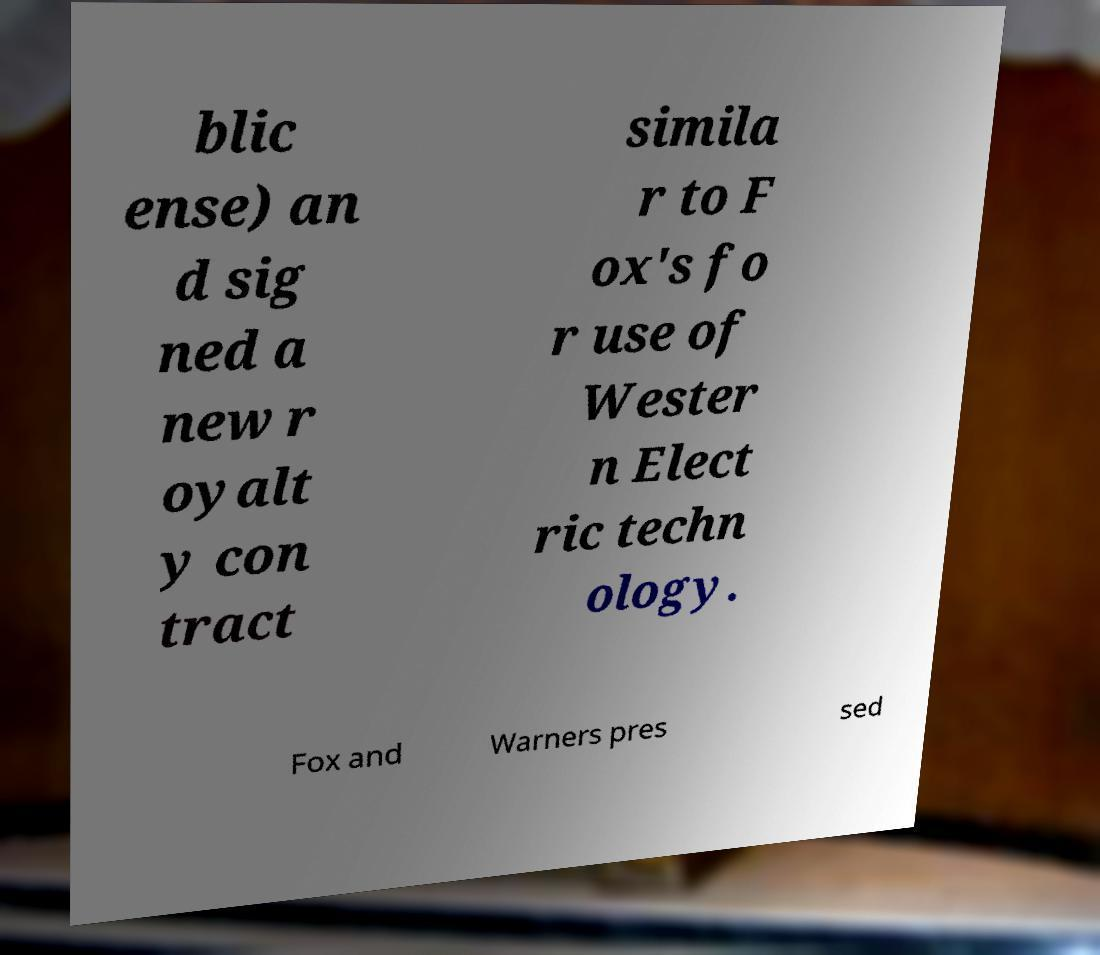Can you read and provide the text displayed in the image?This photo seems to have some interesting text. Can you extract and type it out for me? blic ense) an d sig ned a new r oyalt y con tract simila r to F ox's fo r use of Wester n Elect ric techn ology. Fox and Warners pres sed 